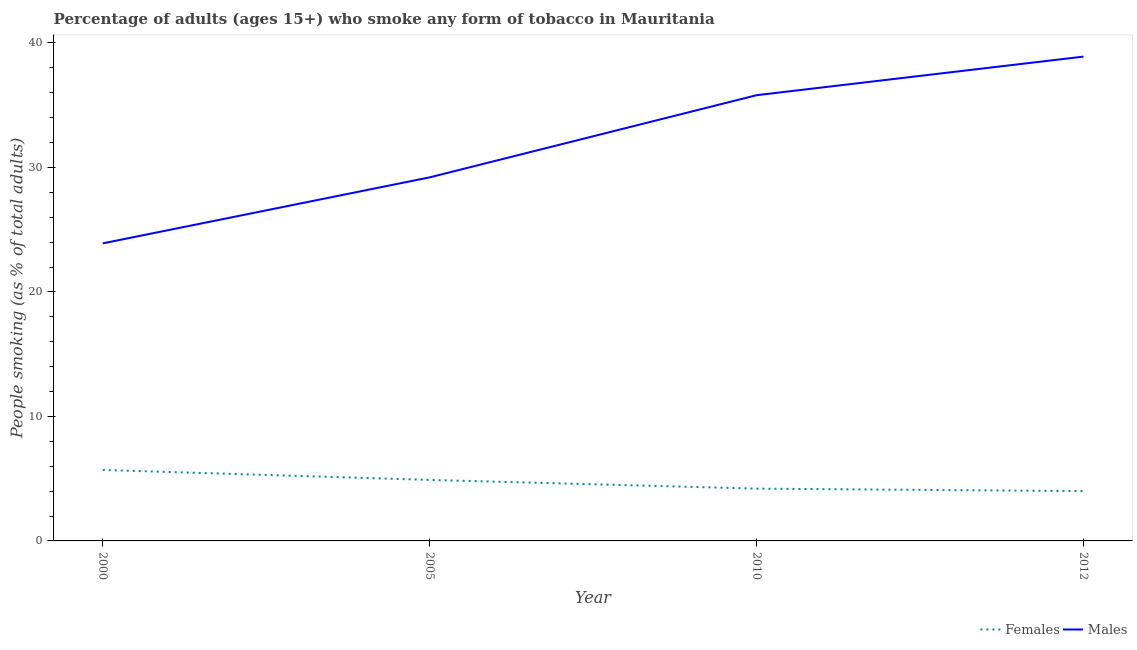Is the number of lines equal to the number of legend labels?
Offer a terse response. Yes. What is the percentage of males who smoke in 2005?
Keep it short and to the point. 29.2. Across all years, what is the minimum percentage of males who smoke?
Offer a very short reply. 23.9. In which year was the percentage of females who smoke minimum?
Your answer should be very brief. 2012. What is the total percentage of males who smoke in the graph?
Give a very brief answer. 127.8. What is the difference between the percentage of females who smoke in 2000 and that in 2010?
Offer a terse response. 1.5. What is the difference between the percentage of males who smoke in 2005 and the percentage of females who smoke in 2012?
Give a very brief answer. 25.2. What is the average percentage of females who smoke per year?
Keep it short and to the point. 4.7. In the year 2000, what is the difference between the percentage of males who smoke and percentage of females who smoke?
Offer a terse response. 18.2. In how many years, is the percentage of females who smoke greater than 22 %?
Your answer should be very brief. 0. What is the ratio of the percentage of females who smoke in 2000 to that in 2012?
Provide a succinct answer. 1.43. Is the percentage of females who smoke in 2005 less than that in 2012?
Ensure brevity in your answer.  No. Is the difference between the percentage of females who smoke in 2000 and 2012 greater than the difference between the percentage of males who smoke in 2000 and 2012?
Provide a short and direct response. Yes. What is the difference between the highest and the second highest percentage of males who smoke?
Offer a terse response. 3.1. What is the difference between the highest and the lowest percentage of females who smoke?
Your answer should be very brief. 1.7. Is the percentage of females who smoke strictly greater than the percentage of males who smoke over the years?
Ensure brevity in your answer.  No. How many years are there in the graph?
Your answer should be very brief. 4. What is the difference between two consecutive major ticks on the Y-axis?
Your response must be concise. 10. Does the graph contain grids?
Make the answer very short. No. How many legend labels are there?
Ensure brevity in your answer.  2. How are the legend labels stacked?
Ensure brevity in your answer.  Horizontal. What is the title of the graph?
Provide a succinct answer. Percentage of adults (ages 15+) who smoke any form of tobacco in Mauritania. Does "Urban Population" appear as one of the legend labels in the graph?
Your answer should be compact. No. What is the label or title of the X-axis?
Keep it short and to the point. Year. What is the label or title of the Y-axis?
Provide a short and direct response. People smoking (as % of total adults). What is the People smoking (as % of total adults) in Males in 2000?
Provide a short and direct response. 23.9. What is the People smoking (as % of total adults) in Females in 2005?
Keep it short and to the point. 4.9. What is the People smoking (as % of total adults) of Males in 2005?
Ensure brevity in your answer.  29.2. What is the People smoking (as % of total adults) in Males in 2010?
Your answer should be very brief. 35.8. What is the People smoking (as % of total adults) in Males in 2012?
Your response must be concise. 38.9. Across all years, what is the maximum People smoking (as % of total adults) of Females?
Your answer should be very brief. 5.7. Across all years, what is the maximum People smoking (as % of total adults) in Males?
Offer a very short reply. 38.9. Across all years, what is the minimum People smoking (as % of total adults) in Males?
Offer a terse response. 23.9. What is the total People smoking (as % of total adults) of Females in the graph?
Offer a terse response. 18.8. What is the total People smoking (as % of total adults) of Males in the graph?
Ensure brevity in your answer.  127.8. What is the difference between the People smoking (as % of total adults) in Females in 2000 and that in 2005?
Provide a short and direct response. 0.8. What is the difference between the People smoking (as % of total adults) of Males in 2000 and that in 2005?
Provide a succinct answer. -5.3. What is the difference between the People smoking (as % of total adults) of Females in 2000 and that in 2010?
Provide a short and direct response. 1.5. What is the difference between the People smoking (as % of total adults) in Females in 2000 and that in 2012?
Ensure brevity in your answer.  1.7. What is the difference between the People smoking (as % of total adults) in Males in 2000 and that in 2012?
Give a very brief answer. -15. What is the difference between the People smoking (as % of total adults) of Females in 2005 and that in 2012?
Provide a short and direct response. 0.9. What is the difference between the People smoking (as % of total adults) of Females in 2010 and that in 2012?
Keep it short and to the point. 0.2. What is the difference between the People smoking (as % of total adults) in Females in 2000 and the People smoking (as % of total adults) in Males in 2005?
Your answer should be compact. -23.5. What is the difference between the People smoking (as % of total adults) of Females in 2000 and the People smoking (as % of total adults) of Males in 2010?
Provide a succinct answer. -30.1. What is the difference between the People smoking (as % of total adults) in Females in 2000 and the People smoking (as % of total adults) in Males in 2012?
Offer a very short reply. -33.2. What is the difference between the People smoking (as % of total adults) of Females in 2005 and the People smoking (as % of total adults) of Males in 2010?
Keep it short and to the point. -30.9. What is the difference between the People smoking (as % of total adults) in Females in 2005 and the People smoking (as % of total adults) in Males in 2012?
Make the answer very short. -34. What is the difference between the People smoking (as % of total adults) in Females in 2010 and the People smoking (as % of total adults) in Males in 2012?
Make the answer very short. -34.7. What is the average People smoking (as % of total adults) of Females per year?
Provide a short and direct response. 4.7. What is the average People smoking (as % of total adults) in Males per year?
Ensure brevity in your answer.  31.95. In the year 2000, what is the difference between the People smoking (as % of total adults) in Females and People smoking (as % of total adults) in Males?
Offer a terse response. -18.2. In the year 2005, what is the difference between the People smoking (as % of total adults) in Females and People smoking (as % of total adults) in Males?
Offer a terse response. -24.3. In the year 2010, what is the difference between the People smoking (as % of total adults) of Females and People smoking (as % of total adults) of Males?
Keep it short and to the point. -31.6. In the year 2012, what is the difference between the People smoking (as % of total adults) of Females and People smoking (as % of total adults) of Males?
Provide a succinct answer. -34.9. What is the ratio of the People smoking (as % of total adults) of Females in 2000 to that in 2005?
Provide a short and direct response. 1.16. What is the ratio of the People smoking (as % of total adults) in Males in 2000 to that in 2005?
Provide a succinct answer. 0.82. What is the ratio of the People smoking (as % of total adults) of Females in 2000 to that in 2010?
Keep it short and to the point. 1.36. What is the ratio of the People smoking (as % of total adults) of Males in 2000 to that in 2010?
Provide a short and direct response. 0.67. What is the ratio of the People smoking (as % of total adults) of Females in 2000 to that in 2012?
Make the answer very short. 1.43. What is the ratio of the People smoking (as % of total adults) in Males in 2000 to that in 2012?
Your answer should be compact. 0.61. What is the ratio of the People smoking (as % of total adults) of Females in 2005 to that in 2010?
Your answer should be compact. 1.17. What is the ratio of the People smoking (as % of total adults) in Males in 2005 to that in 2010?
Offer a terse response. 0.82. What is the ratio of the People smoking (as % of total adults) in Females in 2005 to that in 2012?
Ensure brevity in your answer.  1.23. What is the ratio of the People smoking (as % of total adults) in Males in 2005 to that in 2012?
Your answer should be very brief. 0.75. What is the ratio of the People smoking (as % of total adults) of Males in 2010 to that in 2012?
Keep it short and to the point. 0.92. What is the difference between the highest and the second highest People smoking (as % of total adults) in Females?
Offer a very short reply. 0.8. 